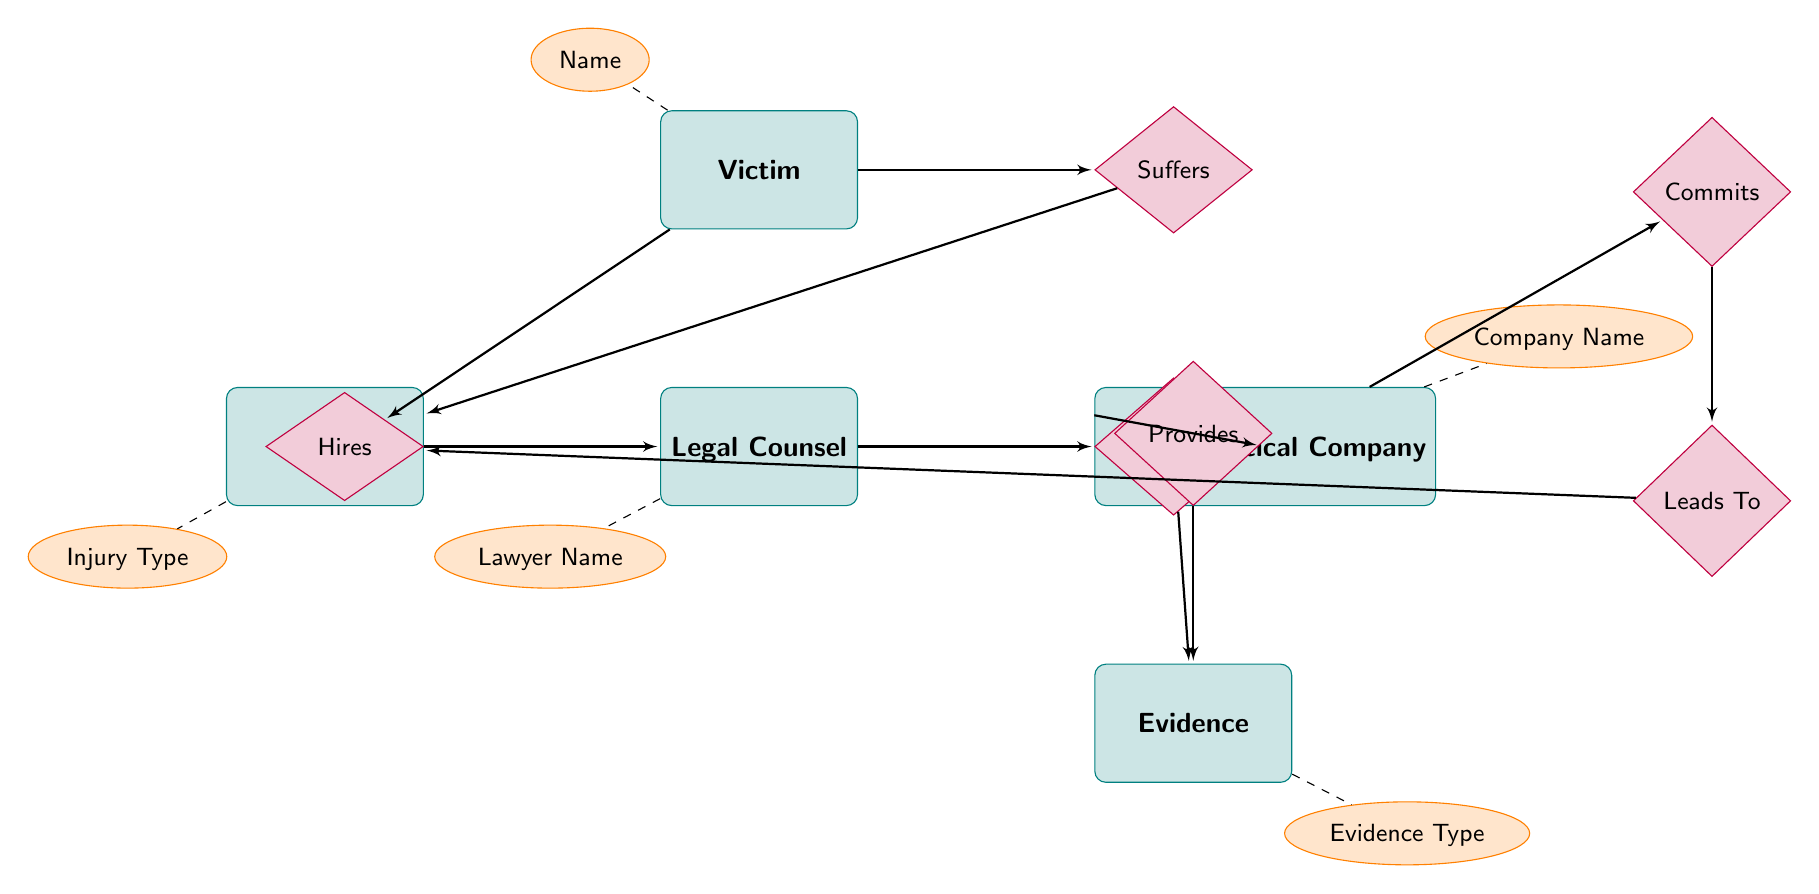What is the main type of relationship between Victim and Injury? The diagram shows that the relationship is labeled "Suffers," which indicates that the Victim experiences or suffers from an Injury.
Answer: Suffers How many entities are present in the diagram? The entities listed in the diagram are Victim, Pharmaceutical Company, Negligent Action, Injury, Legal Counsel, and Evidence. Counting these, there are a total of six entities.
Answer: 6 Who commits the negligent action? The diagram indicates that the Pharmaceutical Company is identified as the entity that "Commits" the negligent action.
Answer: Pharmaceutical Company What type of evidence does Legal Counsel collect? The diagram shows a relationship where Legal Counsel "Collects" Evidence, suggesting the nature of the evidence is related to the legal proceedings associated with the case.
Answer: Evidence What leads to the injury according to the diagram? The diagram demonstrates that the "Negligent Action" leads to the "Injury." This shows that the action taken by the Pharmaceutical Company causes harm to the Victim.
Answer: Negligent Action Which entity does the Victim hire? From the diagram, the victim has a direct relationship that states they "Hires" Legal Counsel, indicating that this is the entity the Victim turns to for legal assistance.
Answer: Legal Counsel What information does the Evidence entity provide? The Evidence entity provides information related to the negligent action and injury, as indicated by the relationship "Provides," which connects it to the Negligent Action.
Answer: Negligent Action What does the Injury entity contain that describes the harm? The attributes of Injury entity include "Injury Type," "Severity," and "Treatment Required," all of which provide essential information about the nature of the injuries suffered by the Victim.
Answer: Injury Type, Severity, Treatment Required Who is responsible for gathering the evidence related to the case? The diagram indicates that it is the Legal Counsel who "Collects" the Evidence necessary to support the case against the Pharmaceutical Company.
Answer: Legal Counsel What relationship exists between Negligent Action and Evidence? The diagram illustrates that the relationship is labeled "Provides," indicating that the Negligent Action supplies or offers Evidence relevant to the case.
Answer: Provides 